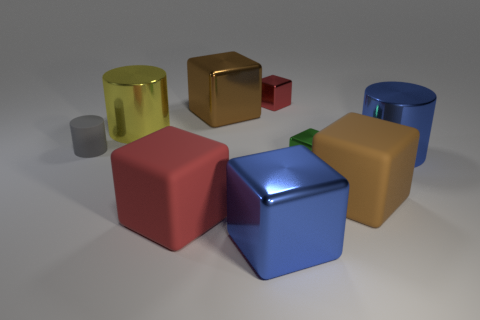Subtract all green cubes. How many cubes are left? 5 Subtract all big blue cubes. How many cubes are left? 5 Subtract all cyan cylinders. Subtract all cyan spheres. How many cylinders are left? 3 Subtract all cubes. How many objects are left? 3 Subtract all shiny cubes. Subtract all green blocks. How many objects are left? 4 Add 2 cylinders. How many cylinders are left? 5 Add 8 large blue metal cylinders. How many large blue metal cylinders exist? 9 Subtract 0 brown cylinders. How many objects are left? 9 